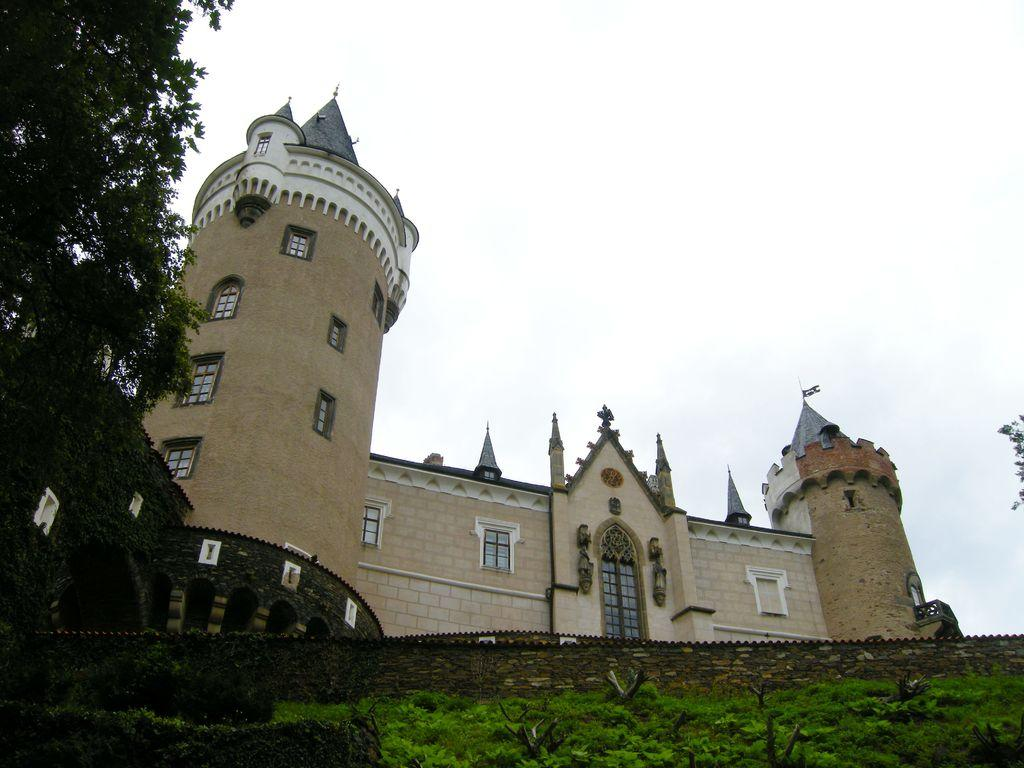What type of structure is present in the image? There is a building in the image. What architectural feature can be seen on the building? There are windows visible on the building. What type of natural vegetation is present in the image? There are trees in the image. What part of the natural environment is visible in the image? The sky is visible in the background of the image. What type of sound can be heard coming from the tent in the image? There is no tent present in the image, so it is not possible to determine what sound might be heard. 